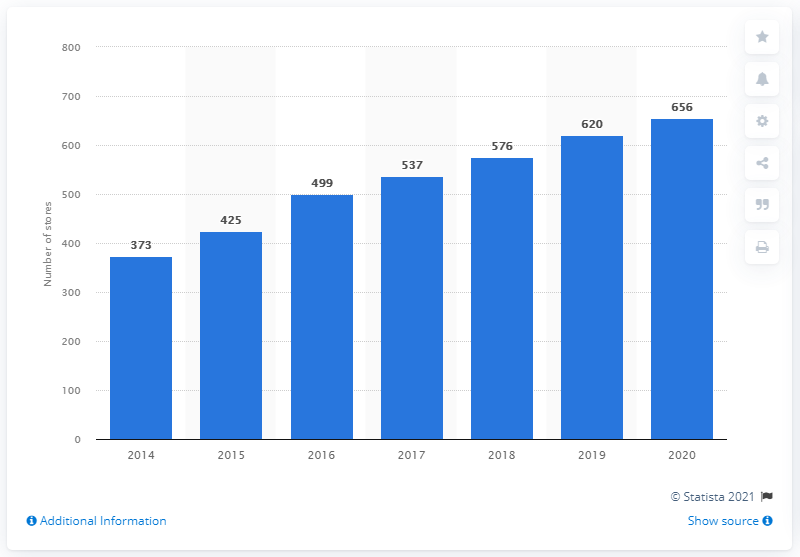Give some essential details in this illustration. In 2020, B&M had a total of 656 stores in the United Kingdom. In 2014, B&M had a total of 373 stores in the UK. 